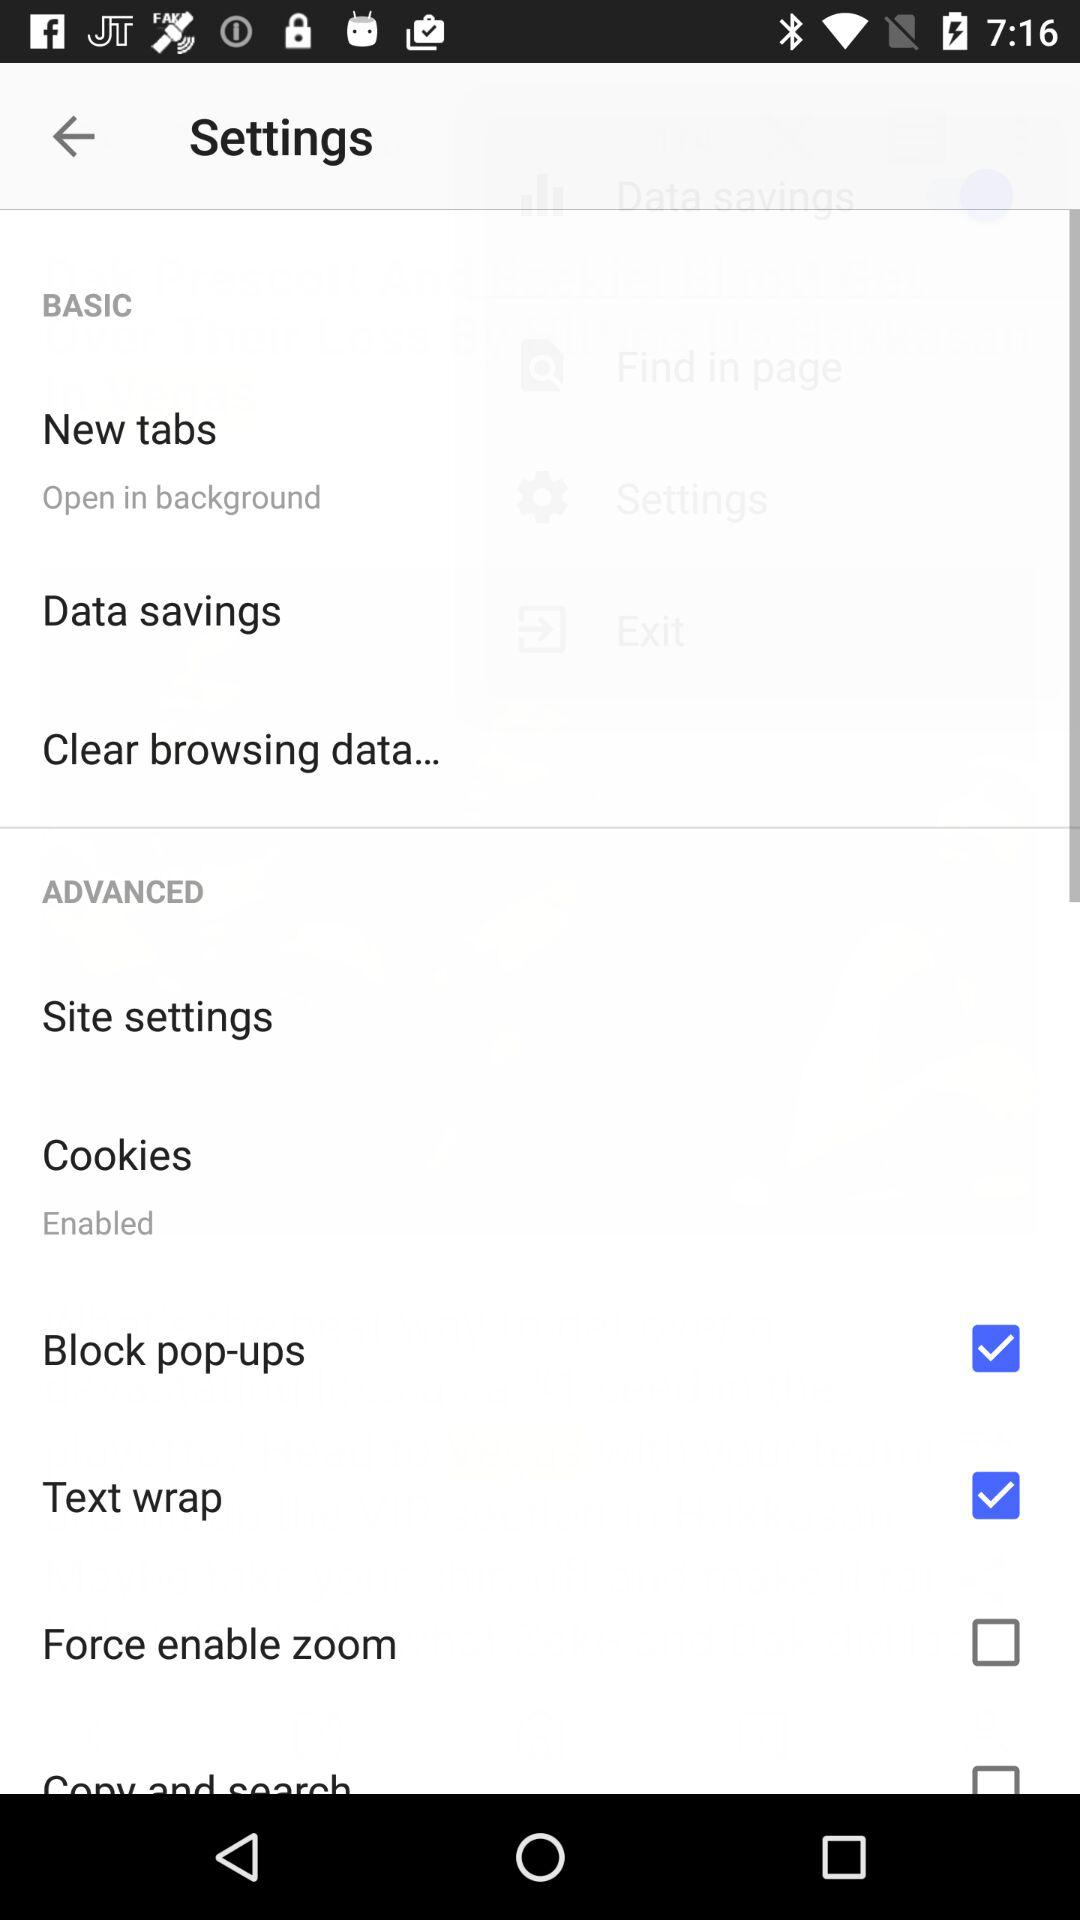How many items have a checkbox in the advanced section?
Answer the question using a single word or phrase. 4 